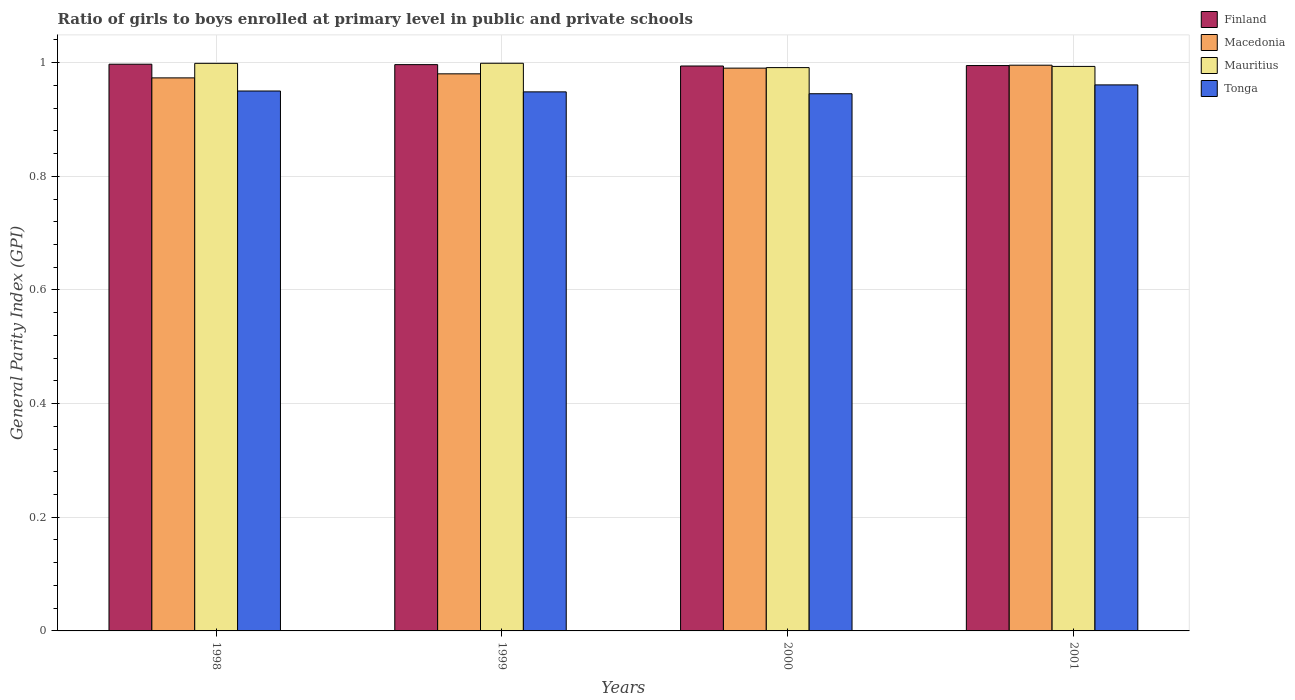How many groups of bars are there?
Make the answer very short. 4. Are the number of bars per tick equal to the number of legend labels?
Provide a succinct answer. Yes. Are the number of bars on each tick of the X-axis equal?
Your response must be concise. Yes. What is the label of the 1st group of bars from the left?
Offer a terse response. 1998. What is the general parity index in Finland in 2000?
Offer a terse response. 0.99. Across all years, what is the maximum general parity index in Macedonia?
Keep it short and to the point. 1. Across all years, what is the minimum general parity index in Tonga?
Your answer should be very brief. 0.95. In which year was the general parity index in Mauritius maximum?
Offer a very short reply. 1999. What is the total general parity index in Finland in the graph?
Ensure brevity in your answer.  3.98. What is the difference between the general parity index in Macedonia in 1999 and that in 2001?
Provide a short and direct response. -0.02. What is the difference between the general parity index in Finland in 2000 and the general parity index in Macedonia in 1999?
Your response must be concise. 0.01. What is the average general parity index in Tonga per year?
Give a very brief answer. 0.95. In the year 2001, what is the difference between the general parity index in Macedonia and general parity index in Tonga?
Keep it short and to the point. 0.03. In how many years, is the general parity index in Mauritius greater than 0.7200000000000001?
Ensure brevity in your answer.  4. What is the ratio of the general parity index in Mauritius in 1998 to that in 2001?
Offer a terse response. 1.01. Is the difference between the general parity index in Macedonia in 1999 and 2001 greater than the difference between the general parity index in Tonga in 1999 and 2001?
Your answer should be very brief. No. What is the difference between the highest and the second highest general parity index in Macedonia?
Provide a succinct answer. 0.01. What is the difference between the highest and the lowest general parity index in Finland?
Provide a succinct answer. 0. Is it the case that in every year, the sum of the general parity index in Tonga and general parity index in Mauritius is greater than the sum of general parity index in Macedonia and general parity index in Finland?
Ensure brevity in your answer.  Yes. What does the 2nd bar from the left in 1998 represents?
Provide a short and direct response. Macedonia. What does the 2nd bar from the right in 1998 represents?
Ensure brevity in your answer.  Mauritius. How many bars are there?
Give a very brief answer. 16. Are all the bars in the graph horizontal?
Offer a terse response. No. What is the difference between two consecutive major ticks on the Y-axis?
Offer a very short reply. 0.2. Are the values on the major ticks of Y-axis written in scientific E-notation?
Your response must be concise. No. Does the graph contain any zero values?
Give a very brief answer. No. Does the graph contain grids?
Give a very brief answer. Yes. How many legend labels are there?
Your response must be concise. 4. How are the legend labels stacked?
Keep it short and to the point. Vertical. What is the title of the graph?
Provide a succinct answer. Ratio of girls to boys enrolled at primary level in public and private schools. Does "European Union" appear as one of the legend labels in the graph?
Keep it short and to the point. No. What is the label or title of the X-axis?
Ensure brevity in your answer.  Years. What is the label or title of the Y-axis?
Your answer should be compact. General Parity Index (GPI). What is the General Parity Index (GPI) in Finland in 1998?
Offer a very short reply. 1. What is the General Parity Index (GPI) of Macedonia in 1998?
Provide a short and direct response. 0.97. What is the General Parity Index (GPI) of Mauritius in 1998?
Offer a very short reply. 1. What is the General Parity Index (GPI) in Tonga in 1998?
Offer a terse response. 0.95. What is the General Parity Index (GPI) in Finland in 1999?
Offer a terse response. 1. What is the General Parity Index (GPI) of Macedonia in 1999?
Offer a very short reply. 0.98. What is the General Parity Index (GPI) in Mauritius in 1999?
Ensure brevity in your answer.  1. What is the General Parity Index (GPI) of Tonga in 1999?
Provide a succinct answer. 0.95. What is the General Parity Index (GPI) in Finland in 2000?
Your answer should be very brief. 0.99. What is the General Parity Index (GPI) of Macedonia in 2000?
Your response must be concise. 0.99. What is the General Parity Index (GPI) of Mauritius in 2000?
Your answer should be compact. 0.99. What is the General Parity Index (GPI) in Tonga in 2000?
Your response must be concise. 0.95. What is the General Parity Index (GPI) of Finland in 2001?
Your answer should be very brief. 0.99. What is the General Parity Index (GPI) of Macedonia in 2001?
Your response must be concise. 1. What is the General Parity Index (GPI) in Mauritius in 2001?
Offer a very short reply. 0.99. What is the General Parity Index (GPI) in Tonga in 2001?
Offer a very short reply. 0.96. Across all years, what is the maximum General Parity Index (GPI) in Finland?
Your response must be concise. 1. Across all years, what is the maximum General Parity Index (GPI) in Macedonia?
Your response must be concise. 1. Across all years, what is the maximum General Parity Index (GPI) of Mauritius?
Your answer should be very brief. 1. Across all years, what is the maximum General Parity Index (GPI) of Tonga?
Offer a very short reply. 0.96. Across all years, what is the minimum General Parity Index (GPI) in Finland?
Offer a terse response. 0.99. Across all years, what is the minimum General Parity Index (GPI) of Macedonia?
Provide a short and direct response. 0.97. Across all years, what is the minimum General Parity Index (GPI) in Mauritius?
Provide a short and direct response. 0.99. Across all years, what is the minimum General Parity Index (GPI) of Tonga?
Offer a very short reply. 0.95. What is the total General Parity Index (GPI) of Finland in the graph?
Keep it short and to the point. 3.98. What is the total General Parity Index (GPI) of Macedonia in the graph?
Offer a terse response. 3.94. What is the total General Parity Index (GPI) in Mauritius in the graph?
Provide a short and direct response. 3.98. What is the total General Parity Index (GPI) of Tonga in the graph?
Provide a short and direct response. 3.8. What is the difference between the General Parity Index (GPI) of Finland in 1998 and that in 1999?
Your response must be concise. 0. What is the difference between the General Parity Index (GPI) in Macedonia in 1998 and that in 1999?
Your answer should be very brief. -0.01. What is the difference between the General Parity Index (GPI) of Mauritius in 1998 and that in 1999?
Ensure brevity in your answer.  -0. What is the difference between the General Parity Index (GPI) in Tonga in 1998 and that in 1999?
Provide a short and direct response. 0. What is the difference between the General Parity Index (GPI) of Finland in 1998 and that in 2000?
Your response must be concise. 0. What is the difference between the General Parity Index (GPI) in Macedonia in 1998 and that in 2000?
Ensure brevity in your answer.  -0.02. What is the difference between the General Parity Index (GPI) in Mauritius in 1998 and that in 2000?
Provide a short and direct response. 0.01. What is the difference between the General Parity Index (GPI) of Tonga in 1998 and that in 2000?
Make the answer very short. 0. What is the difference between the General Parity Index (GPI) in Finland in 1998 and that in 2001?
Keep it short and to the point. 0. What is the difference between the General Parity Index (GPI) of Macedonia in 1998 and that in 2001?
Provide a short and direct response. -0.02. What is the difference between the General Parity Index (GPI) in Mauritius in 1998 and that in 2001?
Offer a very short reply. 0.01. What is the difference between the General Parity Index (GPI) of Tonga in 1998 and that in 2001?
Your answer should be compact. -0.01. What is the difference between the General Parity Index (GPI) of Finland in 1999 and that in 2000?
Ensure brevity in your answer.  0. What is the difference between the General Parity Index (GPI) in Macedonia in 1999 and that in 2000?
Offer a very short reply. -0.01. What is the difference between the General Parity Index (GPI) in Mauritius in 1999 and that in 2000?
Ensure brevity in your answer.  0.01. What is the difference between the General Parity Index (GPI) of Tonga in 1999 and that in 2000?
Provide a short and direct response. 0. What is the difference between the General Parity Index (GPI) in Finland in 1999 and that in 2001?
Give a very brief answer. 0. What is the difference between the General Parity Index (GPI) of Macedonia in 1999 and that in 2001?
Offer a terse response. -0.02. What is the difference between the General Parity Index (GPI) in Mauritius in 1999 and that in 2001?
Offer a very short reply. 0.01. What is the difference between the General Parity Index (GPI) of Tonga in 1999 and that in 2001?
Make the answer very short. -0.01. What is the difference between the General Parity Index (GPI) of Finland in 2000 and that in 2001?
Offer a terse response. -0. What is the difference between the General Parity Index (GPI) in Macedonia in 2000 and that in 2001?
Provide a succinct answer. -0.01. What is the difference between the General Parity Index (GPI) in Mauritius in 2000 and that in 2001?
Ensure brevity in your answer.  -0. What is the difference between the General Parity Index (GPI) of Tonga in 2000 and that in 2001?
Your answer should be very brief. -0.02. What is the difference between the General Parity Index (GPI) in Finland in 1998 and the General Parity Index (GPI) in Macedonia in 1999?
Offer a terse response. 0.02. What is the difference between the General Parity Index (GPI) in Finland in 1998 and the General Parity Index (GPI) in Mauritius in 1999?
Make the answer very short. -0. What is the difference between the General Parity Index (GPI) of Finland in 1998 and the General Parity Index (GPI) of Tonga in 1999?
Offer a very short reply. 0.05. What is the difference between the General Parity Index (GPI) in Macedonia in 1998 and the General Parity Index (GPI) in Mauritius in 1999?
Ensure brevity in your answer.  -0.03. What is the difference between the General Parity Index (GPI) of Macedonia in 1998 and the General Parity Index (GPI) of Tonga in 1999?
Your answer should be compact. 0.02. What is the difference between the General Parity Index (GPI) of Mauritius in 1998 and the General Parity Index (GPI) of Tonga in 1999?
Offer a terse response. 0.05. What is the difference between the General Parity Index (GPI) in Finland in 1998 and the General Parity Index (GPI) in Macedonia in 2000?
Offer a terse response. 0.01. What is the difference between the General Parity Index (GPI) of Finland in 1998 and the General Parity Index (GPI) of Mauritius in 2000?
Make the answer very short. 0.01. What is the difference between the General Parity Index (GPI) in Finland in 1998 and the General Parity Index (GPI) in Tonga in 2000?
Make the answer very short. 0.05. What is the difference between the General Parity Index (GPI) of Macedonia in 1998 and the General Parity Index (GPI) of Mauritius in 2000?
Your response must be concise. -0.02. What is the difference between the General Parity Index (GPI) in Macedonia in 1998 and the General Parity Index (GPI) in Tonga in 2000?
Your answer should be compact. 0.03. What is the difference between the General Parity Index (GPI) of Mauritius in 1998 and the General Parity Index (GPI) of Tonga in 2000?
Give a very brief answer. 0.05. What is the difference between the General Parity Index (GPI) in Finland in 1998 and the General Parity Index (GPI) in Macedonia in 2001?
Keep it short and to the point. 0. What is the difference between the General Parity Index (GPI) in Finland in 1998 and the General Parity Index (GPI) in Mauritius in 2001?
Offer a very short reply. 0. What is the difference between the General Parity Index (GPI) in Finland in 1998 and the General Parity Index (GPI) in Tonga in 2001?
Ensure brevity in your answer.  0.04. What is the difference between the General Parity Index (GPI) in Macedonia in 1998 and the General Parity Index (GPI) in Mauritius in 2001?
Your answer should be very brief. -0.02. What is the difference between the General Parity Index (GPI) in Macedonia in 1998 and the General Parity Index (GPI) in Tonga in 2001?
Give a very brief answer. 0.01. What is the difference between the General Parity Index (GPI) in Mauritius in 1998 and the General Parity Index (GPI) in Tonga in 2001?
Ensure brevity in your answer.  0.04. What is the difference between the General Parity Index (GPI) of Finland in 1999 and the General Parity Index (GPI) of Macedonia in 2000?
Keep it short and to the point. 0.01. What is the difference between the General Parity Index (GPI) in Finland in 1999 and the General Parity Index (GPI) in Mauritius in 2000?
Make the answer very short. 0.01. What is the difference between the General Parity Index (GPI) in Finland in 1999 and the General Parity Index (GPI) in Tonga in 2000?
Offer a very short reply. 0.05. What is the difference between the General Parity Index (GPI) of Macedonia in 1999 and the General Parity Index (GPI) of Mauritius in 2000?
Ensure brevity in your answer.  -0.01. What is the difference between the General Parity Index (GPI) of Macedonia in 1999 and the General Parity Index (GPI) of Tonga in 2000?
Provide a short and direct response. 0.04. What is the difference between the General Parity Index (GPI) of Mauritius in 1999 and the General Parity Index (GPI) of Tonga in 2000?
Offer a terse response. 0.05. What is the difference between the General Parity Index (GPI) in Finland in 1999 and the General Parity Index (GPI) in Mauritius in 2001?
Your answer should be compact. 0. What is the difference between the General Parity Index (GPI) in Finland in 1999 and the General Parity Index (GPI) in Tonga in 2001?
Your answer should be compact. 0.04. What is the difference between the General Parity Index (GPI) in Macedonia in 1999 and the General Parity Index (GPI) in Mauritius in 2001?
Offer a very short reply. -0.01. What is the difference between the General Parity Index (GPI) in Macedonia in 1999 and the General Parity Index (GPI) in Tonga in 2001?
Your answer should be compact. 0.02. What is the difference between the General Parity Index (GPI) of Mauritius in 1999 and the General Parity Index (GPI) of Tonga in 2001?
Offer a very short reply. 0.04. What is the difference between the General Parity Index (GPI) of Finland in 2000 and the General Parity Index (GPI) of Macedonia in 2001?
Make the answer very short. -0. What is the difference between the General Parity Index (GPI) in Finland in 2000 and the General Parity Index (GPI) in Mauritius in 2001?
Your answer should be very brief. 0. What is the difference between the General Parity Index (GPI) of Finland in 2000 and the General Parity Index (GPI) of Tonga in 2001?
Your answer should be very brief. 0.03. What is the difference between the General Parity Index (GPI) of Macedonia in 2000 and the General Parity Index (GPI) of Mauritius in 2001?
Give a very brief answer. -0. What is the difference between the General Parity Index (GPI) in Macedonia in 2000 and the General Parity Index (GPI) in Tonga in 2001?
Your response must be concise. 0.03. What is the difference between the General Parity Index (GPI) of Mauritius in 2000 and the General Parity Index (GPI) of Tonga in 2001?
Offer a terse response. 0.03. What is the average General Parity Index (GPI) in Finland per year?
Ensure brevity in your answer.  1. What is the average General Parity Index (GPI) of Macedonia per year?
Provide a succinct answer. 0.98. What is the average General Parity Index (GPI) of Mauritius per year?
Provide a short and direct response. 1. What is the average General Parity Index (GPI) in Tonga per year?
Ensure brevity in your answer.  0.95. In the year 1998, what is the difference between the General Parity Index (GPI) in Finland and General Parity Index (GPI) in Macedonia?
Provide a succinct answer. 0.02. In the year 1998, what is the difference between the General Parity Index (GPI) of Finland and General Parity Index (GPI) of Mauritius?
Provide a succinct answer. -0. In the year 1998, what is the difference between the General Parity Index (GPI) of Finland and General Parity Index (GPI) of Tonga?
Give a very brief answer. 0.05. In the year 1998, what is the difference between the General Parity Index (GPI) in Macedonia and General Parity Index (GPI) in Mauritius?
Make the answer very short. -0.03. In the year 1998, what is the difference between the General Parity Index (GPI) in Macedonia and General Parity Index (GPI) in Tonga?
Offer a very short reply. 0.02. In the year 1998, what is the difference between the General Parity Index (GPI) in Mauritius and General Parity Index (GPI) in Tonga?
Your answer should be compact. 0.05. In the year 1999, what is the difference between the General Parity Index (GPI) in Finland and General Parity Index (GPI) in Macedonia?
Your answer should be very brief. 0.02. In the year 1999, what is the difference between the General Parity Index (GPI) in Finland and General Parity Index (GPI) in Mauritius?
Your answer should be very brief. -0. In the year 1999, what is the difference between the General Parity Index (GPI) in Finland and General Parity Index (GPI) in Tonga?
Provide a short and direct response. 0.05. In the year 1999, what is the difference between the General Parity Index (GPI) in Macedonia and General Parity Index (GPI) in Mauritius?
Give a very brief answer. -0.02. In the year 1999, what is the difference between the General Parity Index (GPI) in Macedonia and General Parity Index (GPI) in Tonga?
Your response must be concise. 0.03. In the year 1999, what is the difference between the General Parity Index (GPI) in Mauritius and General Parity Index (GPI) in Tonga?
Make the answer very short. 0.05. In the year 2000, what is the difference between the General Parity Index (GPI) in Finland and General Parity Index (GPI) in Macedonia?
Give a very brief answer. 0. In the year 2000, what is the difference between the General Parity Index (GPI) of Finland and General Parity Index (GPI) of Mauritius?
Your answer should be very brief. 0. In the year 2000, what is the difference between the General Parity Index (GPI) in Finland and General Parity Index (GPI) in Tonga?
Your response must be concise. 0.05. In the year 2000, what is the difference between the General Parity Index (GPI) in Macedonia and General Parity Index (GPI) in Mauritius?
Provide a short and direct response. -0. In the year 2000, what is the difference between the General Parity Index (GPI) of Macedonia and General Parity Index (GPI) of Tonga?
Your answer should be compact. 0.05. In the year 2000, what is the difference between the General Parity Index (GPI) of Mauritius and General Parity Index (GPI) of Tonga?
Make the answer very short. 0.05. In the year 2001, what is the difference between the General Parity Index (GPI) of Finland and General Parity Index (GPI) of Macedonia?
Offer a very short reply. -0. In the year 2001, what is the difference between the General Parity Index (GPI) of Finland and General Parity Index (GPI) of Mauritius?
Offer a terse response. 0. In the year 2001, what is the difference between the General Parity Index (GPI) in Finland and General Parity Index (GPI) in Tonga?
Your answer should be very brief. 0.03. In the year 2001, what is the difference between the General Parity Index (GPI) in Macedonia and General Parity Index (GPI) in Mauritius?
Ensure brevity in your answer.  0. In the year 2001, what is the difference between the General Parity Index (GPI) of Macedonia and General Parity Index (GPI) of Tonga?
Make the answer very short. 0.03. In the year 2001, what is the difference between the General Parity Index (GPI) of Mauritius and General Parity Index (GPI) of Tonga?
Provide a short and direct response. 0.03. What is the ratio of the General Parity Index (GPI) in Mauritius in 1998 to that in 1999?
Your answer should be compact. 1. What is the ratio of the General Parity Index (GPI) in Tonga in 1998 to that in 1999?
Provide a succinct answer. 1. What is the ratio of the General Parity Index (GPI) of Macedonia in 1998 to that in 2000?
Your response must be concise. 0.98. What is the ratio of the General Parity Index (GPI) in Mauritius in 1998 to that in 2000?
Provide a short and direct response. 1.01. What is the ratio of the General Parity Index (GPI) of Macedonia in 1998 to that in 2001?
Make the answer very short. 0.98. What is the ratio of the General Parity Index (GPI) of Mauritius in 1998 to that in 2001?
Provide a succinct answer. 1.01. What is the ratio of the General Parity Index (GPI) of Finland in 1999 to that in 2000?
Give a very brief answer. 1. What is the ratio of the General Parity Index (GPI) in Mauritius in 1999 to that in 2000?
Provide a succinct answer. 1.01. What is the ratio of the General Parity Index (GPI) of Tonga in 1999 to that in 2000?
Your answer should be compact. 1. What is the ratio of the General Parity Index (GPI) in Finland in 1999 to that in 2001?
Make the answer very short. 1. What is the ratio of the General Parity Index (GPI) of Macedonia in 1999 to that in 2001?
Your answer should be compact. 0.98. What is the ratio of the General Parity Index (GPI) in Mauritius in 1999 to that in 2001?
Provide a short and direct response. 1.01. What is the ratio of the General Parity Index (GPI) in Tonga in 1999 to that in 2001?
Provide a succinct answer. 0.99. What is the ratio of the General Parity Index (GPI) in Finland in 2000 to that in 2001?
Give a very brief answer. 1. What is the ratio of the General Parity Index (GPI) of Macedonia in 2000 to that in 2001?
Provide a short and direct response. 0.99. What is the ratio of the General Parity Index (GPI) in Tonga in 2000 to that in 2001?
Your response must be concise. 0.98. What is the difference between the highest and the second highest General Parity Index (GPI) of Finland?
Your answer should be compact. 0. What is the difference between the highest and the second highest General Parity Index (GPI) of Macedonia?
Provide a short and direct response. 0.01. What is the difference between the highest and the second highest General Parity Index (GPI) of Tonga?
Give a very brief answer. 0.01. What is the difference between the highest and the lowest General Parity Index (GPI) of Finland?
Offer a very short reply. 0. What is the difference between the highest and the lowest General Parity Index (GPI) in Macedonia?
Offer a very short reply. 0.02. What is the difference between the highest and the lowest General Parity Index (GPI) in Mauritius?
Your answer should be very brief. 0.01. What is the difference between the highest and the lowest General Parity Index (GPI) in Tonga?
Provide a short and direct response. 0.02. 